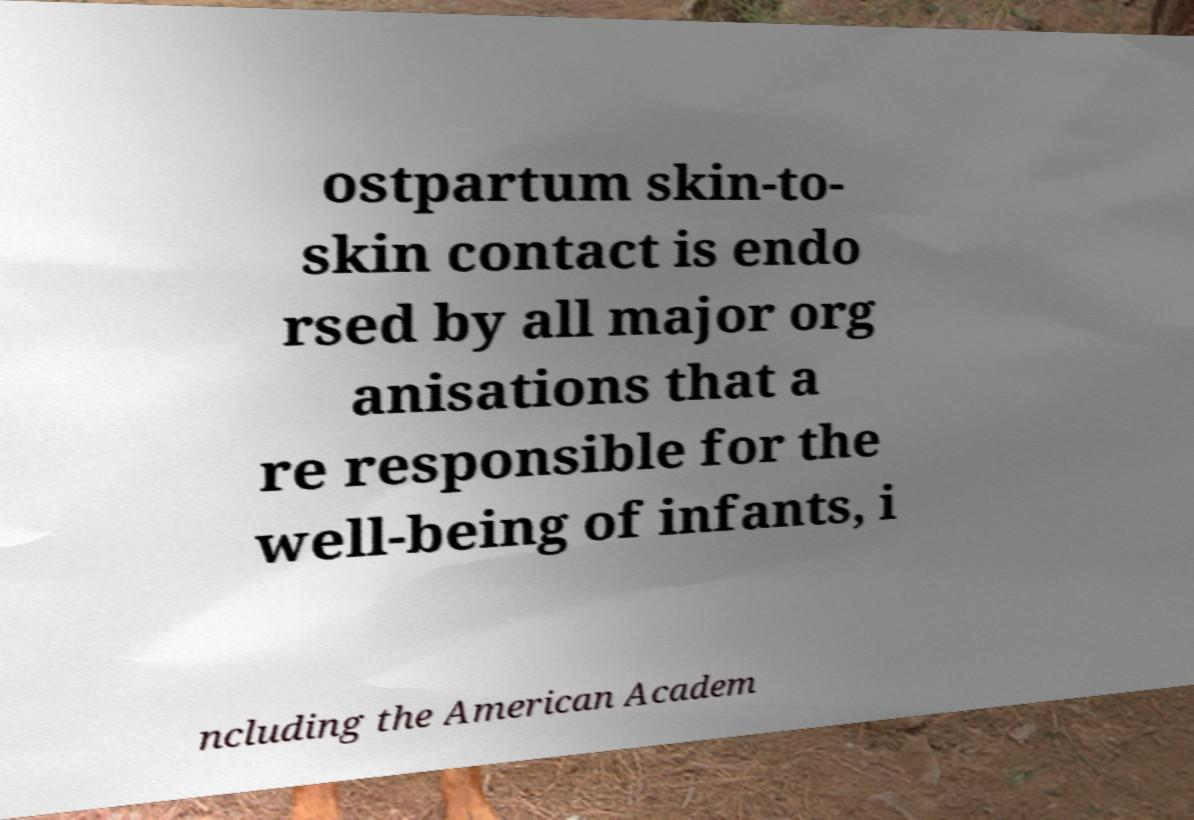Could you extract and type out the text from this image? ostpartum skin-to- skin contact is endo rsed by all major org anisations that a re responsible for the well-being of infants, i ncluding the American Academ 